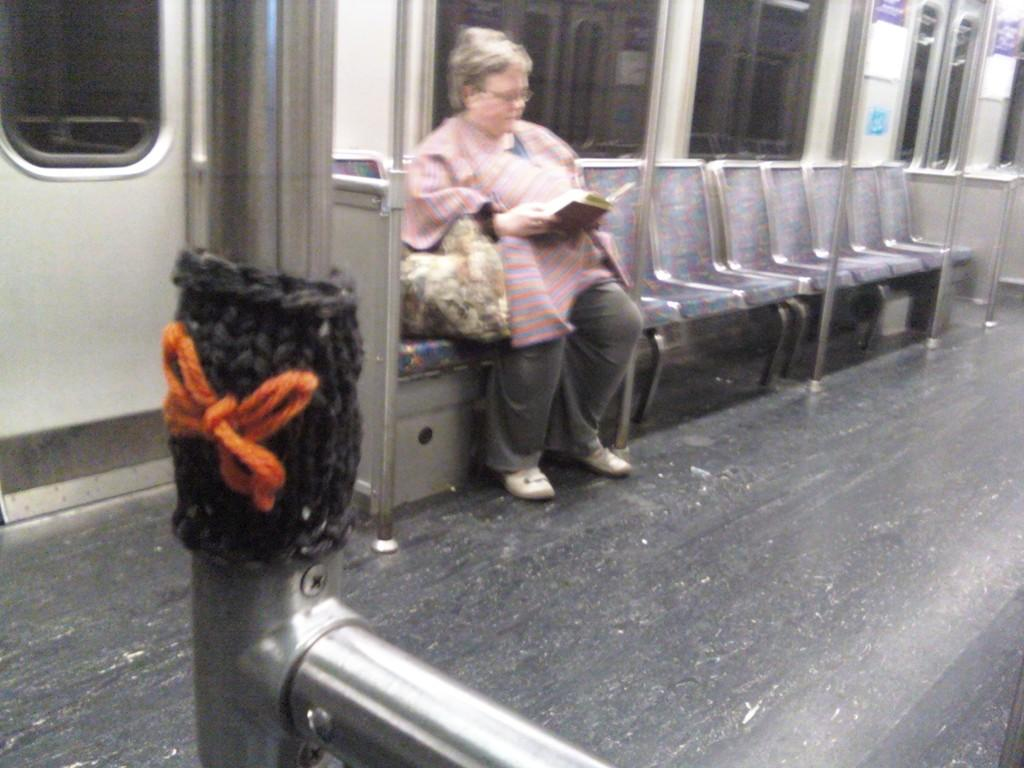What type of location is shown in the image? The image depicts the interior of a train. What is the woman in the image doing? The woman is sitting in a chair and holding a book in her hand. Are there any other chairs visible in the image? Yes, there are empty chairs in the image. What can be seen beside the woman? There are poles beside the woman. What type of ink is the beggar using to write a letter in the image? There is no beggar present in the image, and therefore no ink or letter-writing activity can be observed. 